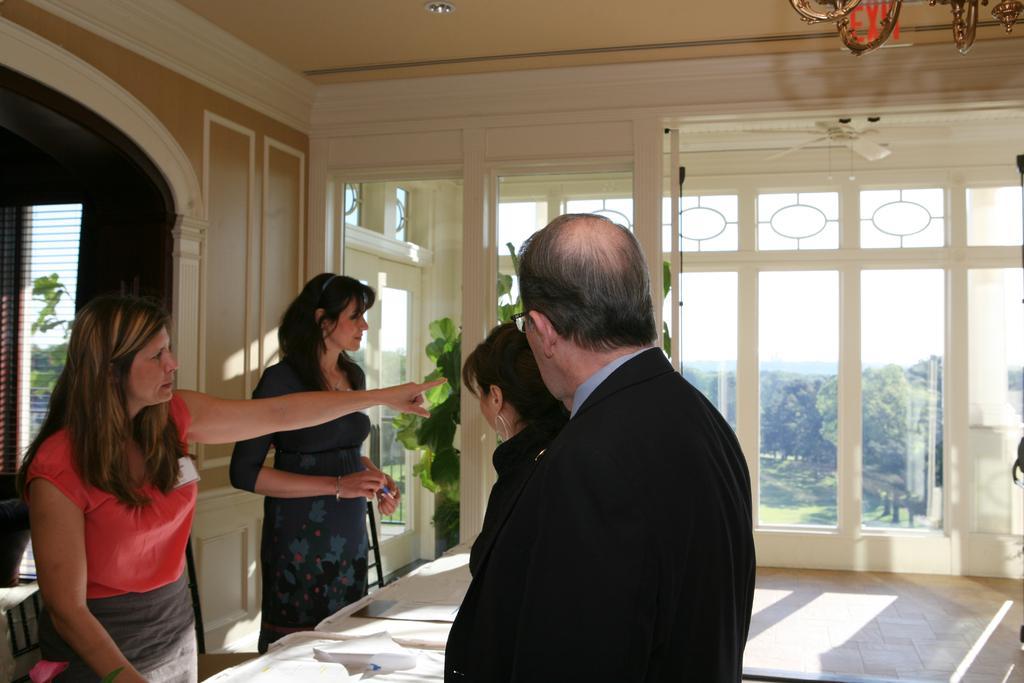In one or two sentences, can you explain what this image depicts? In this image there are three women and a man, in middle there is a table, in the background there is a glass door through that door trees and sky are visible. 